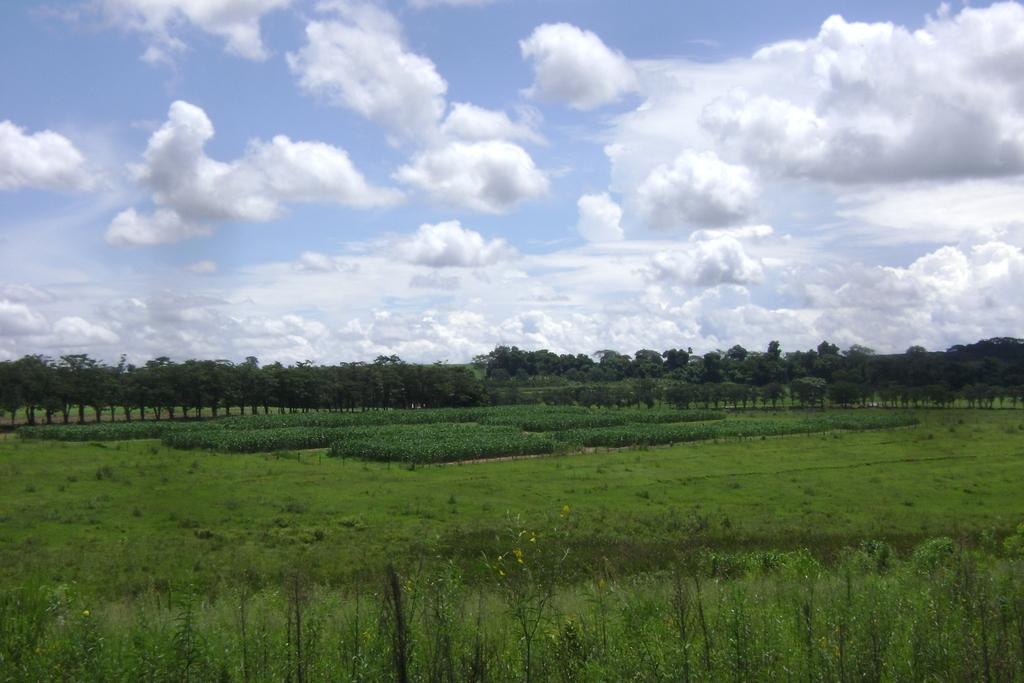What type of vegetation is at the bottom of the image? There is grass and plants at the bottom of the image. What can be seen in the background of the image? There are trees in the background of the image. What is visible at the top of the image? The sky is visible at the top of the image. What can be observed in the sky? Clouds are present in the sky. How does the cow contribute to the tax system in the image? There is no cow present in the image, so it cannot contribute to the tax system. 